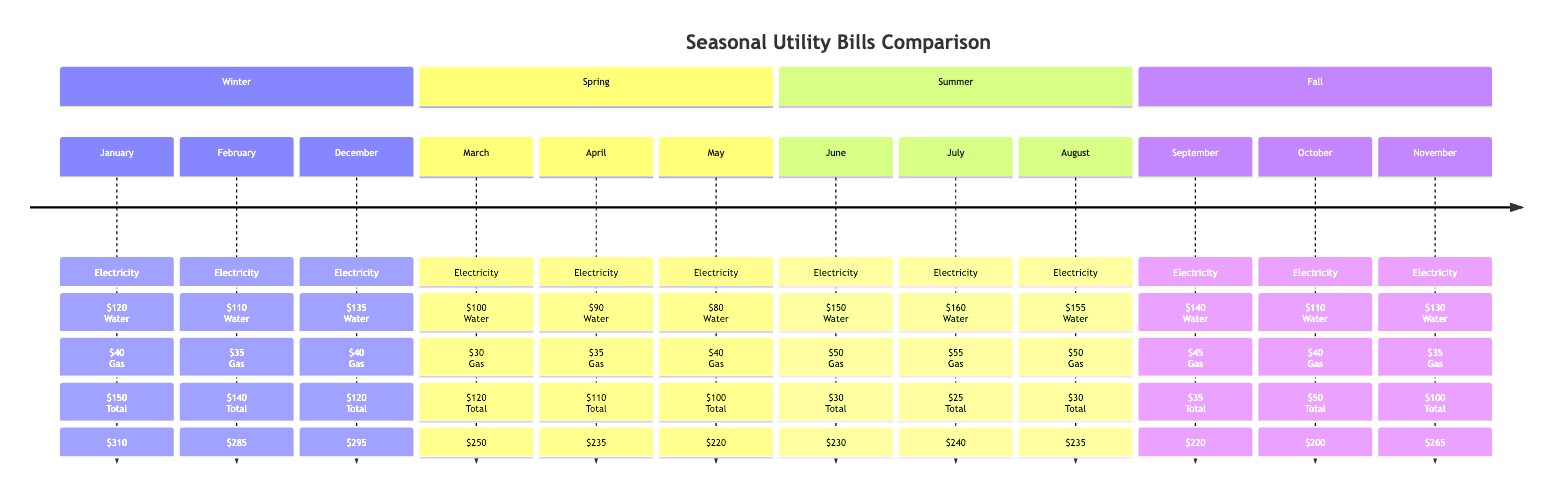What is the total utility cost for July? The total utility cost for July can be found in the summer section of the diagram. For July, the total cost listed is $240.
Answer: 240 Which month has the highest electricity bill? To determine which month has the highest electricity bill, we scan through all the months listed. July shows the highest electricity bill of $160.
Answer: 160 What is the total bill for the month of April? In the spring section, April's total cost is mentioned directly and is $235.
Answer: 235 How does the gas bill in March compare to the gas bill in November? By comparing the gas bill values directly from both months, March has a gas bill of $120, while November has a gas bill of $100. Therefore, March's gas bill is higher than November's.
Answer: Higher In which season is the electricity bill consistently the lowest? By looking at the electricity bills for each season, spring has the lowest electricity bills at $100, $90, and $80 for March, April, and May, respectively.
Answer: Spring What is the difference in total utility cost between January and February? To find the difference, we subtract February's total cost of $285 from January's total cost of $310. The difference is $310 - $285 = $25.
Answer: 25 How many months fall under the summer season? By examining the timeline, we see that there are three months listed under the summer section: June, July, and August. Hence, the total is three months.
Answer: 3 Which month has the lowest total utility bill? Looking at the total costs for each month, we find October has the lowest total utility bill of $200.
Answer: 200 What is the water bill amount for September? September's water bill is specifically listed as $45 in the fall section of the timeline.
Answer: 45 